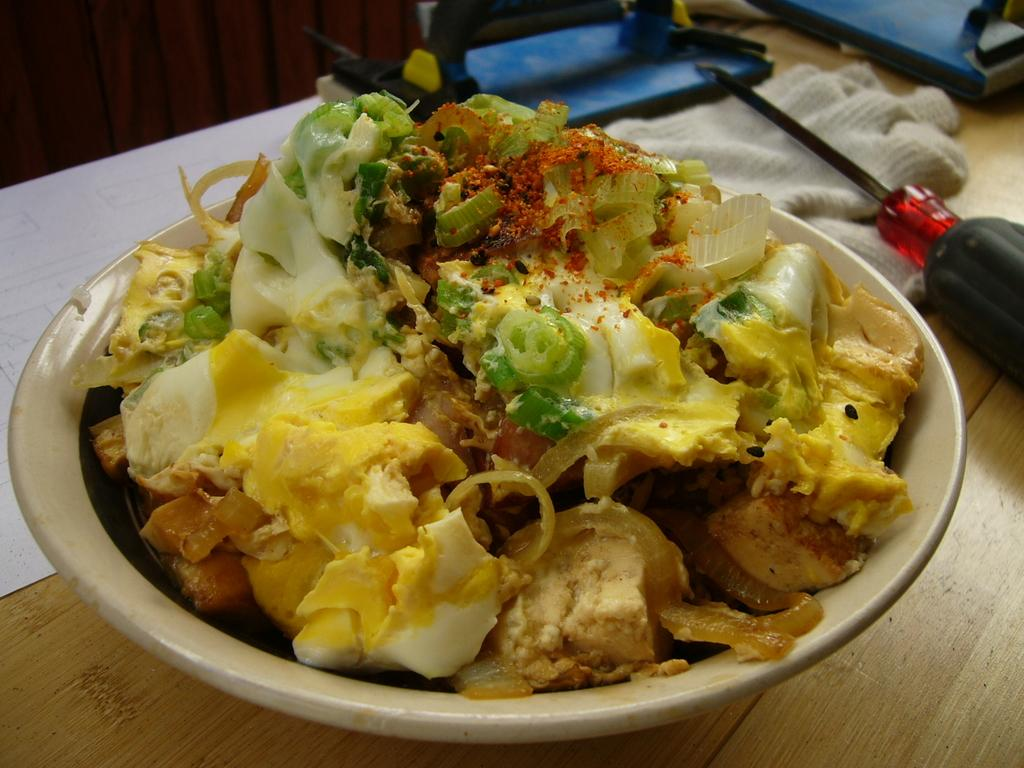What type of surface is visible in the image? There is a table in the image. What is placed on the table? There is paper, cloth, a screwdriver, a bowl, a food item, and other objects on the table. Can you describe the paper on the table? The paper is on the table, but its specific details are not mentioned in the facts. What is the food item on the table? The facts mention that there is a food item on the table, but its specific details are not provided. How many birds are sitting on the leg of the table in the image? There are no birds present in the image, so it is not possible to answer that question. 